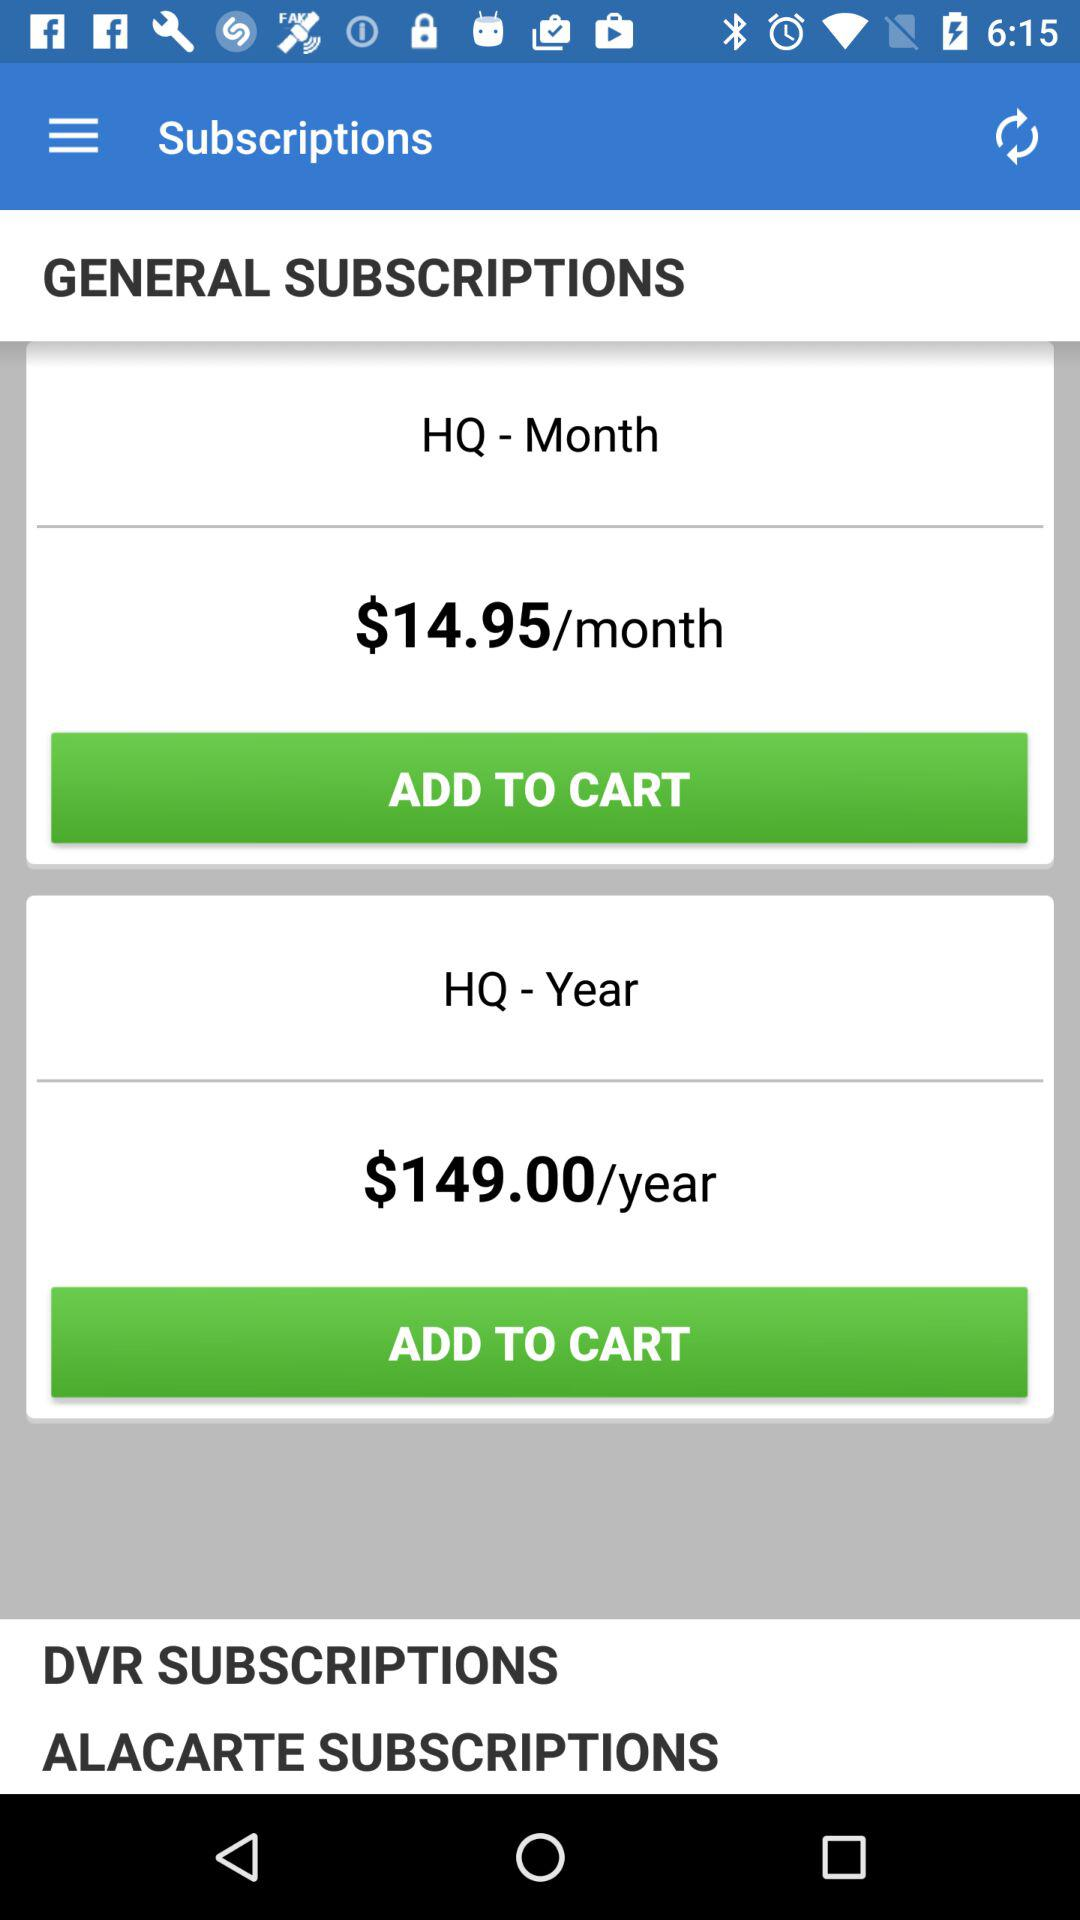How much will I have to pay for the yearly subscription? You will have to pay $149 for the yearly subscription. 